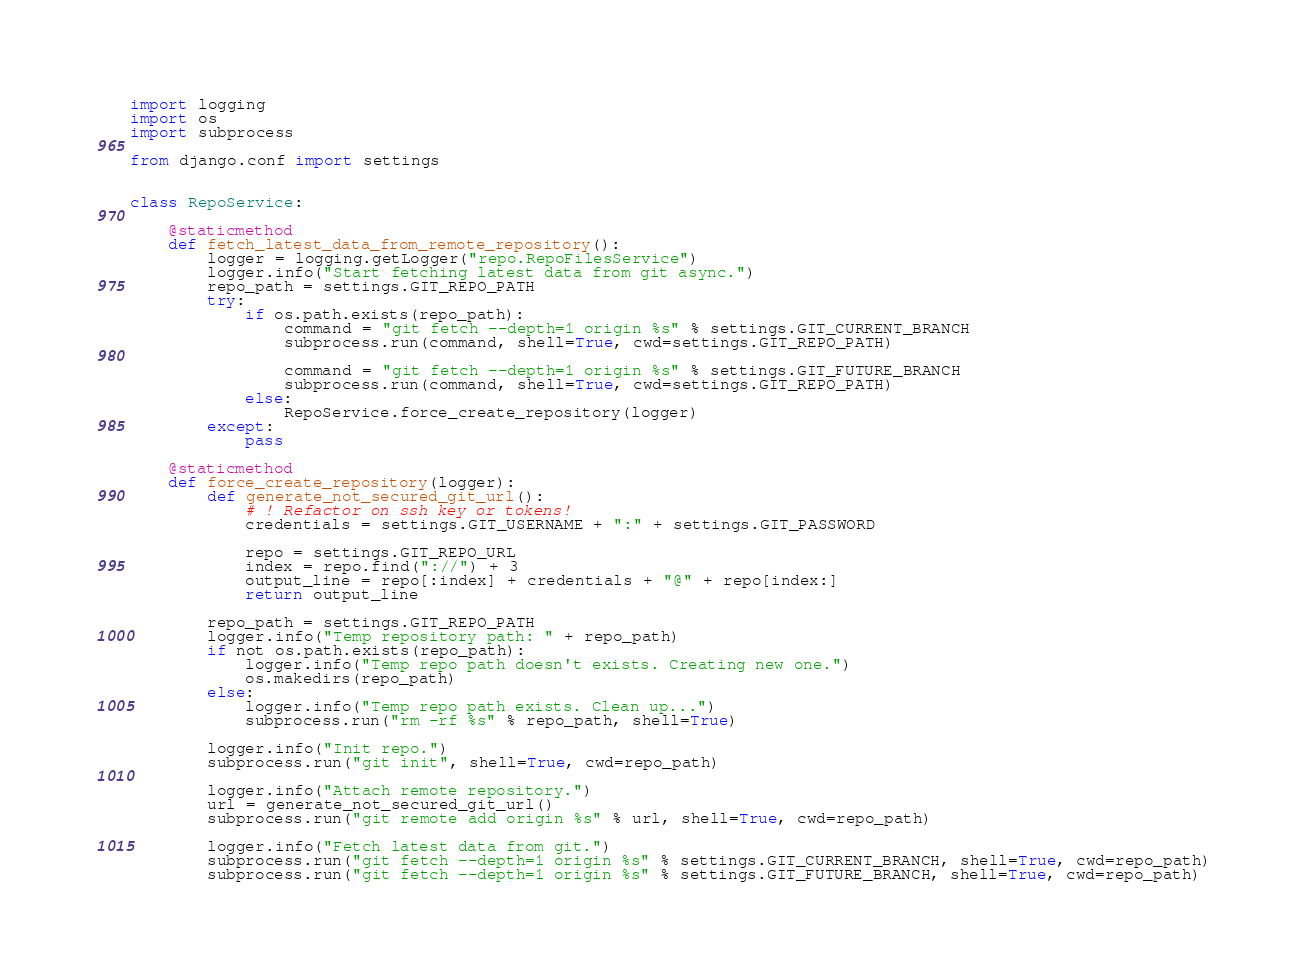<code> <loc_0><loc_0><loc_500><loc_500><_Python_>import logging
import os
import subprocess

from django.conf import settings


class RepoService:

    @staticmethod
    def fetch_latest_data_from_remote_repository():
        logger = logging.getLogger("repo.RepoFilesService")
        logger.info("Start fetching latest data from git async.")
        repo_path = settings.GIT_REPO_PATH
        try:
            if os.path.exists(repo_path):
                command = "git fetch --depth=1 origin %s" % settings.GIT_CURRENT_BRANCH
                subprocess.run(command, shell=True, cwd=settings.GIT_REPO_PATH)

                command = "git fetch --depth=1 origin %s" % settings.GIT_FUTURE_BRANCH
                subprocess.run(command, shell=True, cwd=settings.GIT_REPO_PATH)
            else:
                RepoService.force_create_repository(logger)
        except:
            pass

    @staticmethod
    def force_create_repository(logger):
        def generate_not_secured_git_url():
            # ! Refactor on ssh key or tokens!
            credentials = settings.GIT_USERNAME + ":" + settings.GIT_PASSWORD

            repo = settings.GIT_REPO_URL
            index = repo.find("://") + 3
            output_line = repo[:index] + credentials + "@" + repo[index:]
            return output_line

        repo_path = settings.GIT_REPO_PATH
        logger.info("Temp repository path: " + repo_path)
        if not os.path.exists(repo_path):
            logger.info("Temp repo path doesn't exists. Creating new one.")
            os.makedirs(repo_path)
        else:
            logger.info("Temp repo path exists. Clean up...")
            subprocess.run("rm -rf %s" % repo_path, shell=True)

        logger.info("Init repo.")
        subprocess.run("git init", shell=True, cwd=repo_path)

        logger.info("Attach remote repository.")
        url = generate_not_secured_git_url()
        subprocess.run("git remote add origin %s" % url, shell=True, cwd=repo_path)

        logger.info("Fetch latest data from git.")
        subprocess.run("git fetch --depth=1 origin %s" % settings.GIT_CURRENT_BRANCH, shell=True, cwd=repo_path)
        subprocess.run("git fetch --depth=1 origin %s" % settings.GIT_FUTURE_BRANCH, shell=True, cwd=repo_path)
</code> 